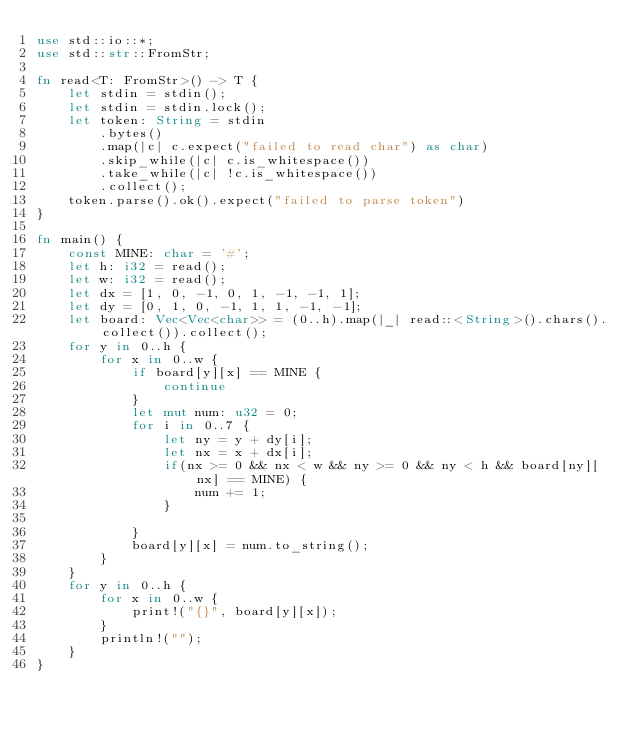Convert code to text. <code><loc_0><loc_0><loc_500><loc_500><_Rust_>use std::io::*;
use std::str::FromStr;

fn read<T: FromStr>() -> T {
    let stdin = stdin();
    let stdin = stdin.lock();
    let token: String = stdin
        .bytes()
        .map(|c| c.expect("failed to read char") as char)
        .skip_while(|c| c.is_whitespace())
        .take_while(|c| !c.is_whitespace())
        .collect();
    token.parse().ok().expect("failed to parse token")
}

fn main() {
    const MINE: char = '#';
    let h: i32 = read();
    let w: i32 = read();
    let dx = [1, 0, -1, 0, 1, -1, -1, 1];
    let dy = [0, 1, 0, -1, 1, 1, -1, -1];
    let board: Vec<Vec<char>> = (0..h).map(|_| read::<String>().chars().collect()).collect();
    for y in 0..h {
        for x in 0..w {
            if board[y][x] == MINE {
                continue
            }
            let mut num: u32 = 0;
            for i in 0..7 {
                let ny = y + dy[i];
                let nx = x + dx[i];
                if(nx >= 0 && nx < w && ny >= 0 && ny < h && board[ny][nx] == MINE) {
                    num += 1;
                }

            }
            board[y][x] = num.to_string();
        }
    }
    for y in 0..h {
        for x in 0..w {
            print!("{}", board[y][x]);
        }
        println!("");
    }
}</code> 